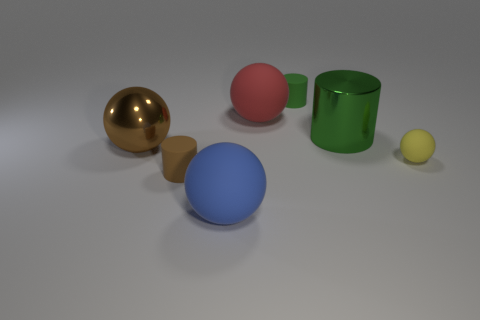What can the lighting in the scene tell us about the objects? The lighting offers soft shadows and subtle highlights on the objects, suggesting a diffuse light source, which gives the scene a calm, realistic look. It accentuates the smooth texture of the objects and allows their colors to appear true to life. 